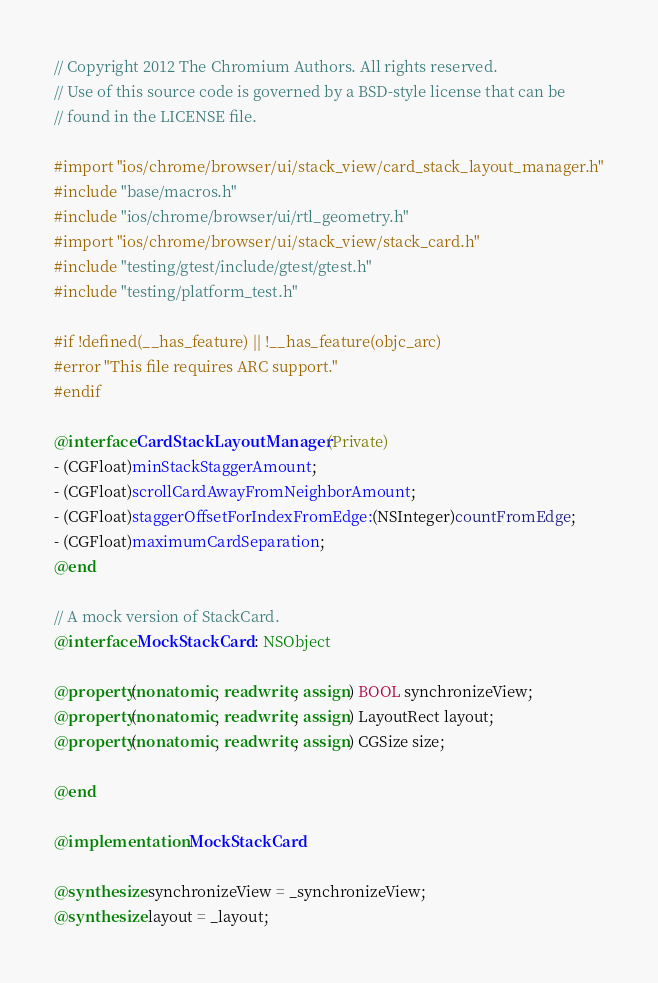<code> <loc_0><loc_0><loc_500><loc_500><_ObjectiveC_>// Copyright 2012 The Chromium Authors. All rights reserved.
// Use of this source code is governed by a BSD-style license that can be
// found in the LICENSE file.

#import "ios/chrome/browser/ui/stack_view/card_stack_layout_manager.h"
#include "base/macros.h"
#include "ios/chrome/browser/ui/rtl_geometry.h"
#import "ios/chrome/browser/ui/stack_view/stack_card.h"
#include "testing/gtest/include/gtest/gtest.h"
#include "testing/platform_test.h"

#if !defined(__has_feature) || !__has_feature(objc_arc)
#error "This file requires ARC support."
#endif

@interface CardStackLayoutManager (Private)
- (CGFloat)minStackStaggerAmount;
- (CGFloat)scrollCardAwayFromNeighborAmount;
- (CGFloat)staggerOffsetForIndexFromEdge:(NSInteger)countFromEdge;
- (CGFloat)maximumCardSeparation;
@end

// A mock version of StackCard.
@interface MockStackCard : NSObject

@property(nonatomic, readwrite, assign) BOOL synchronizeView;
@property(nonatomic, readwrite, assign) LayoutRect layout;
@property(nonatomic, readwrite, assign) CGSize size;

@end

@implementation MockStackCard

@synthesize synchronizeView = _synchronizeView;
@synthesize layout = _layout;</code> 